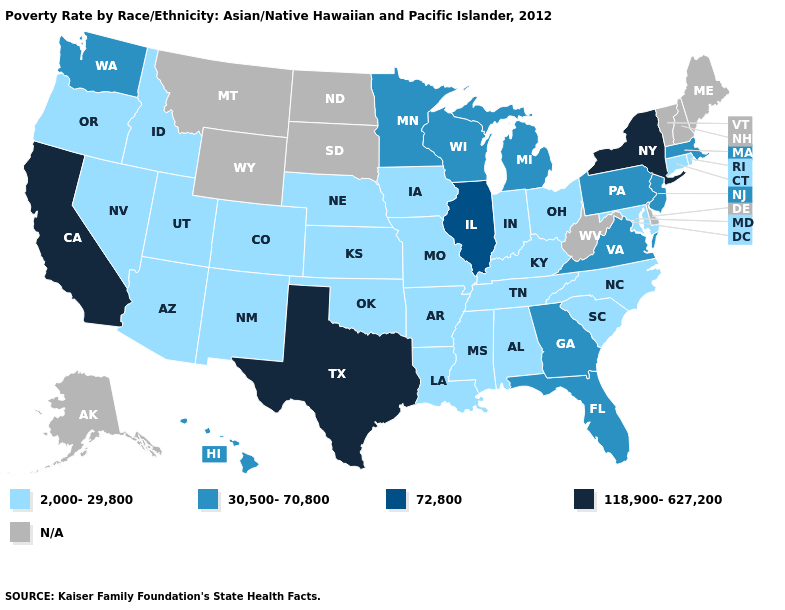What is the highest value in states that border Vermont?
Write a very short answer. 118,900-627,200. Does Minnesota have the lowest value in the MidWest?
Keep it brief. No. How many symbols are there in the legend?
Give a very brief answer. 5. Among the states that border Massachusetts , which have the lowest value?
Quick response, please. Connecticut, Rhode Island. Name the states that have a value in the range 72,800?
Be succinct. Illinois. Name the states that have a value in the range 118,900-627,200?
Be succinct. California, New York, Texas. Which states have the lowest value in the Northeast?
Write a very short answer. Connecticut, Rhode Island. What is the highest value in the USA?
Concise answer only. 118,900-627,200. Which states have the lowest value in the West?
Give a very brief answer. Arizona, Colorado, Idaho, Nevada, New Mexico, Oregon, Utah. Name the states that have a value in the range 30,500-70,800?
Be succinct. Florida, Georgia, Hawaii, Massachusetts, Michigan, Minnesota, New Jersey, Pennsylvania, Virginia, Washington, Wisconsin. Which states have the lowest value in the USA?
Keep it brief. Alabama, Arizona, Arkansas, Colorado, Connecticut, Idaho, Indiana, Iowa, Kansas, Kentucky, Louisiana, Maryland, Mississippi, Missouri, Nebraska, Nevada, New Mexico, North Carolina, Ohio, Oklahoma, Oregon, Rhode Island, South Carolina, Tennessee, Utah. Name the states that have a value in the range N/A?
Give a very brief answer. Alaska, Delaware, Maine, Montana, New Hampshire, North Dakota, South Dakota, Vermont, West Virginia, Wyoming. Among the states that border Oklahoma , which have the highest value?
Answer briefly. Texas. Does Rhode Island have the highest value in the Northeast?
Keep it brief. No. How many symbols are there in the legend?
Quick response, please. 5. 